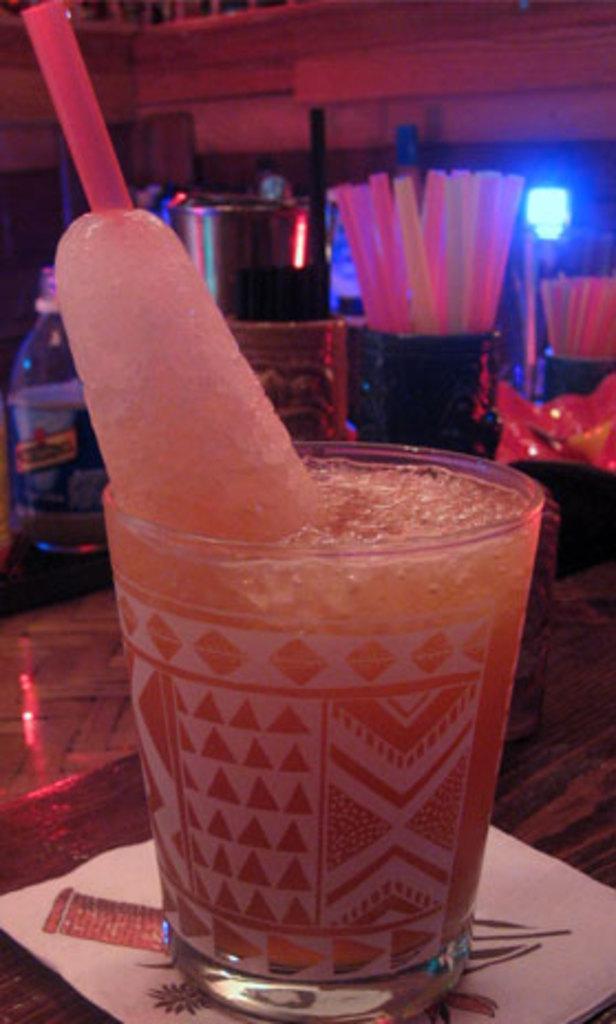How would you summarize this image in a sentence or two? In this image there is a ice gola in the glass which was placed on top of the table. At the back side there are few other items. 